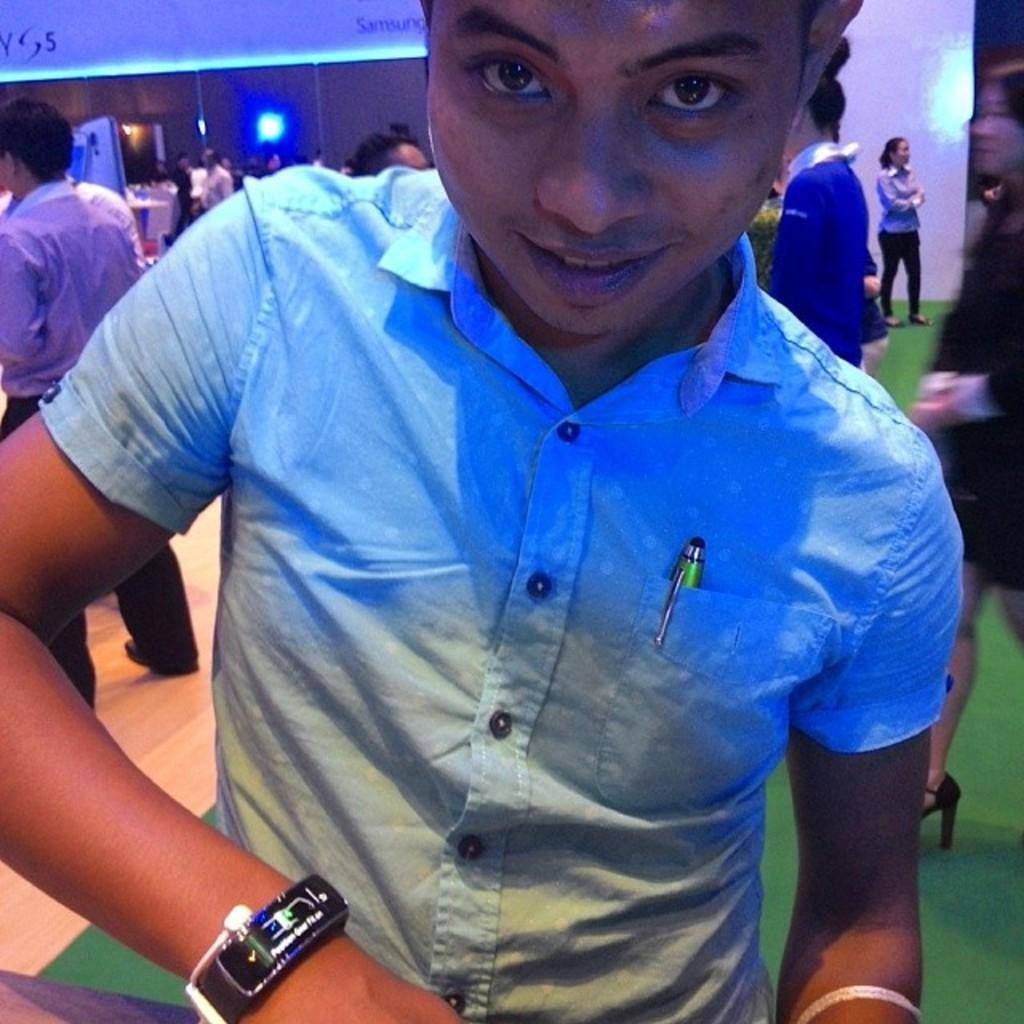What is the main subject of the image? There is a person standing in the image. Can you describe the person's clothing? The person is wearing a blue shirt. Are there any other people visible in the image? Yes, there are other persons standing in the background of the image. What color is the wall in the image? There is a brown-colored wall in the image. What can be seen in the image that provides illumination? There are lights visible in the image. Can you tell me how many squirrels are sitting on the person's shoulder in the image? There are no squirrels present in the image, so it is not possible to determine how many might be sitting on the person's shoulder. What type of wine is being served in the image? There is no wine present in the image, so it cannot be determined what type might be served. 